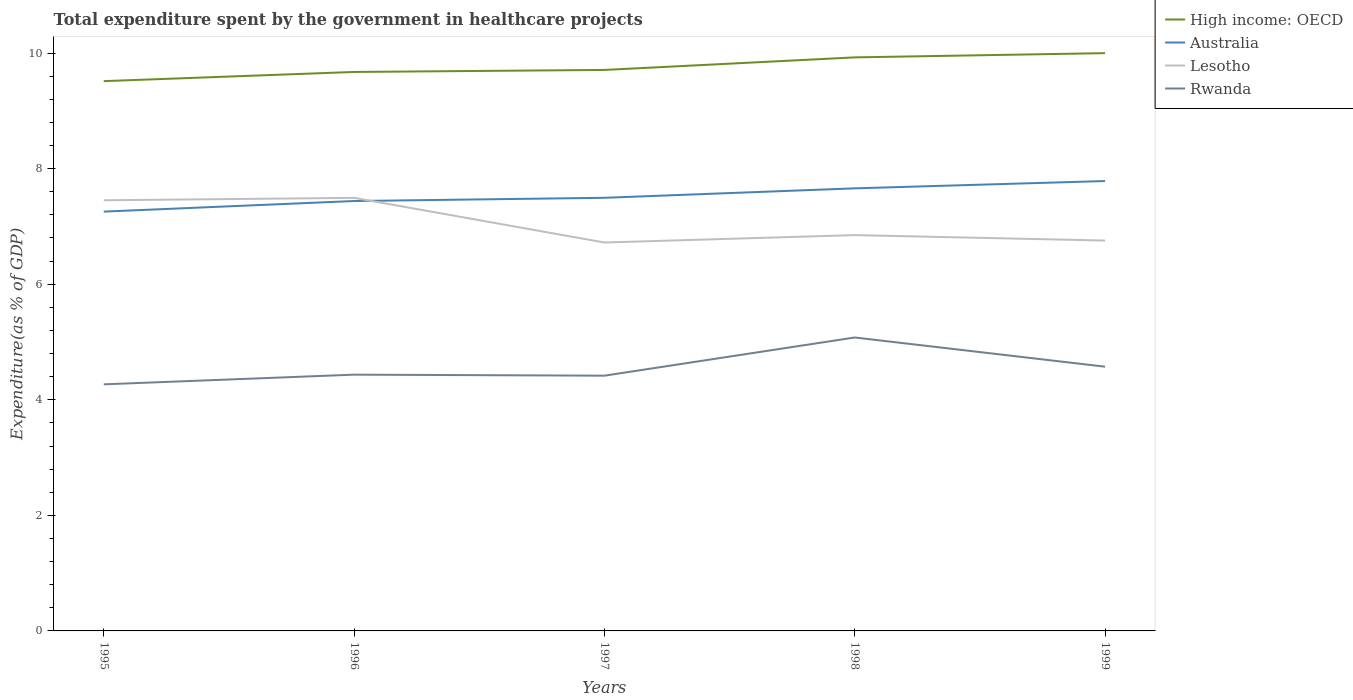How many different coloured lines are there?
Your answer should be compact. 4. Does the line corresponding to Lesotho intersect with the line corresponding to Rwanda?
Your answer should be very brief. No. Across all years, what is the maximum total expenditure spent by the government in healthcare projects in Australia?
Provide a succinct answer. 7.26. In which year was the total expenditure spent by the government in healthcare projects in Lesotho maximum?
Give a very brief answer. 1997. What is the total total expenditure spent by the government in healthcare projects in Australia in the graph?
Your answer should be compact. -0.24. What is the difference between the highest and the second highest total expenditure spent by the government in healthcare projects in Australia?
Your answer should be compact. 0.53. What is the difference between the highest and the lowest total expenditure spent by the government in healthcare projects in High income: OECD?
Give a very brief answer. 2. How many lines are there?
Make the answer very short. 4. How many years are there in the graph?
Your response must be concise. 5. What is the difference between two consecutive major ticks on the Y-axis?
Provide a succinct answer. 2. Does the graph contain any zero values?
Your answer should be compact. No. Does the graph contain grids?
Offer a very short reply. No. How many legend labels are there?
Keep it short and to the point. 4. How are the legend labels stacked?
Offer a terse response. Vertical. What is the title of the graph?
Offer a terse response. Total expenditure spent by the government in healthcare projects. Does "Kenya" appear as one of the legend labels in the graph?
Keep it short and to the point. No. What is the label or title of the X-axis?
Offer a very short reply. Years. What is the label or title of the Y-axis?
Provide a succinct answer. Expenditure(as % of GDP). What is the Expenditure(as % of GDP) of High income: OECD in 1995?
Your response must be concise. 9.51. What is the Expenditure(as % of GDP) in Australia in 1995?
Make the answer very short. 7.26. What is the Expenditure(as % of GDP) in Lesotho in 1995?
Your response must be concise. 7.45. What is the Expenditure(as % of GDP) in Rwanda in 1995?
Your answer should be compact. 4.27. What is the Expenditure(as % of GDP) of High income: OECD in 1996?
Your answer should be compact. 9.67. What is the Expenditure(as % of GDP) in Australia in 1996?
Offer a terse response. 7.44. What is the Expenditure(as % of GDP) of Lesotho in 1996?
Your response must be concise. 7.49. What is the Expenditure(as % of GDP) of Rwanda in 1996?
Provide a succinct answer. 4.44. What is the Expenditure(as % of GDP) of High income: OECD in 1997?
Provide a short and direct response. 9.71. What is the Expenditure(as % of GDP) of Australia in 1997?
Ensure brevity in your answer.  7.5. What is the Expenditure(as % of GDP) of Lesotho in 1997?
Make the answer very short. 6.72. What is the Expenditure(as % of GDP) in Rwanda in 1997?
Offer a very short reply. 4.42. What is the Expenditure(as % of GDP) of High income: OECD in 1998?
Your answer should be very brief. 9.93. What is the Expenditure(as % of GDP) of Australia in 1998?
Give a very brief answer. 7.66. What is the Expenditure(as % of GDP) of Lesotho in 1998?
Provide a succinct answer. 6.85. What is the Expenditure(as % of GDP) in Rwanda in 1998?
Offer a terse response. 5.08. What is the Expenditure(as % of GDP) in High income: OECD in 1999?
Your response must be concise. 10. What is the Expenditure(as % of GDP) of Australia in 1999?
Your response must be concise. 7.79. What is the Expenditure(as % of GDP) in Lesotho in 1999?
Offer a terse response. 6.76. What is the Expenditure(as % of GDP) of Rwanda in 1999?
Offer a terse response. 4.57. Across all years, what is the maximum Expenditure(as % of GDP) in High income: OECD?
Your response must be concise. 10. Across all years, what is the maximum Expenditure(as % of GDP) in Australia?
Keep it short and to the point. 7.79. Across all years, what is the maximum Expenditure(as % of GDP) of Lesotho?
Your answer should be compact. 7.49. Across all years, what is the maximum Expenditure(as % of GDP) of Rwanda?
Your response must be concise. 5.08. Across all years, what is the minimum Expenditure(as % of GDP) of High income: OECD?
Provide a short and direct response. 9.51. Across all years, what is the minimum Expenditure(as % of GDP) in Australia?
Provide a succinct answer. 7.26. Across all years, what is the minimum Expenditure(as % of GDP) of Lesotho?
Ensure brevity in your answer.  6.72. Across all years, what is the minimum Expenditure(as % of GDP) of Rwanda?
Offer a very short reply. 4.27. What is the total Expenditure(as % of GDP) in High income: OECD in the graph?
Provide a short and direct response. 48.82. What is the total Expenditure(as % of GDP) of Australia in the graph?
Your answer should be compact. 37.64. What is the total Expenditure(as % of GDP) in Lesotho in the graph?
Provide a short and direct response. 35.27. What is the total Expenditure(as % of GDP) of Rwanda in the graph?
Provide a succinct answer. 22.77. What is the difference between the Expenditure(as % of GDP) of High income: OECD in 1995 and that in 1996?
Your answer should be compact. -0.16. What is the difference between the Expenditure(as % of GDP) of Australia in 1995 and that in 1996?
Your answer should be very brief. -0.18. What is the difference between the Expenditure(as % of GDP) of Lesotho in 1995 and that in 1996?
Provide a succinct answer. -0.04. What is the difference between the Expenditure(as % of GDP) in Rwanda in 1995 and that in 1996?
Provide a succinct answer. -0.17. What is the difference between the Expenditure(as % of GDP) of High income: OECD in 1995 and that in 1997?
Give a very brief answer. -0.19. What is the difference between the Expenditure(as % of GDP) of Australia in 1995 and that in 1997?
Your answer should be very brief. -0.24. What is the difference between the Expenditure(as % of GDP) in Lesotho in 1995 and that in 1997?
Your answer should be compact. 0.73. What is the difference between the Expenditure(as % of GDP) of Rwanda in 1995 and that in 1997?
Make the answer very short. -0.15. What is the difference between the Expenditure(as % of GDP) in High income: OECD in 1995 and that in 1998?
Keep it short and to the point. -0.41. What is the difference between the Expenditure(as % of GDP) of Australia in 1995 and that in 1998?
Keep it short and to the point. -0.4. What is the difference between the Expenditure(as % of GDP) in Lesotho in 1995 and that in 1998?
Offer a very short reply. 0.6. What is the difference between the Expenditure(as % of GDP) in Rwanda in 1995 and that in 1998?
Provide a short and direct response. -0.81. What is the difference between the Expenditure(as % of GDP) of High income: OECD in 1995 and that in 1999?
Provide a succinct answer. -0.48. What is the difference between the Expenditure(as % of GDP) in Australia in 1995 and that in 1999?
Keep it short and to the point. -0.53. What is the difference between the Expenditure(as % of GDP) in Lesotho in 1995 and that in 1999?
Your answer should be compact. 0.7. What is the difference between the Expenditure(as % of GDP) of Rwanda in 1995 and that in 1999?
Your answer should be compact. -0.31. What is the difference between the Expenditure(as % of GDP) of High income: OECD in 1996 and that in 1997?
Make the answer very short. -0.03. What is the difference between the Expenditure(as % of GDP) of Australia in 1996 and that in 1997?
Give a very brief answer. -0.06. What is the difference between the Expenditure(as % of GDP) in Lesotho in 1996 and that in 1997?
Your response must be concise. 0.77. What is the difference between the Expenditure(as % of GDP) in Rwanda in 1996 and that in 1997?
Ensure brevity in your answer.  0.02. What is the difference between the Expenditure(as % of GDP) of High income: OECD in 1996 and that in 1998?
Keep it short and to the point. -0.25. What is the difference between the Expenditure(as % of GDP) of Australia in 1996 and that in 1998?
Offer a terse response. -0.22. What is the difference between the Expenditure(as % of GDP) in Lesotho in 1996 and that in 1998?
Give a very brief answer. 0.64. What is the difference between the Expenditure(as % of GDP) of Rwanda in 1996 and that in 1998?
Offer a terse response. -0.64. What is the difference between the Expenditure(as % of GDP) in High income: OECD in 1996 and that in 1999?
Ensure brevity in your answer.  -0.33. What is the difference between the Expenditure(as % of GDP) of Australia in 1996 and that in 1999?
Your answer should be compact. -0.35. What is the difference between the Expenditure(as % of GDP) in Lesotho in 1996 and that in 1999?
Give a very brief answer. 0.74. What is the difference between the Expenditure(as % of GDP) of Rwanda in 1996 and that in 1999?
Provide a succinct answer. -0.14. What is the difference between the Expenditure(as % of GDP) of High income: OECD in 1997 and that in 1998?
Offer a terse response. -0.22. What is the difference between the Expenditure(as % of GDP) of Australia in 1997 and that in 1998?
Your answer should be compact. -0.16. What is the difference between the Expenditure(as % of GDP) of Lesotho in 1997 and that in 1998?
Offer a terse response. -0.13. What is the difference between the Expenditure(as % of GDP) of Rwanda in 1997 and that in 1998?
Keep it short and to the point. -0.66. What is the difference between the Expenditure(as % of GDP) in High income: OECD in 1997 and that in 1999?
Offer a very short reply. -0.29. What is the difference between the Expenditure(as % of GDP) in Australia in 1997 and that in 1999?
Give a very brief answer. -0.29. What is the difference between the Expenditure(as % of GDP) in Lesotho in 1997 and that in 1999?
Offer a terse response. -0.03. What is the difference between the Expenditure(as % of GDP) of Rwanda in 1997 and that in 1999?
Offer a terse response. -0.16. What is the difference between the Expenditure(as % of GDP) in High income: OECD in 1998 and that in 1999?
Give a very brief answer. -0.07. What is the difference between the Expenditure(as % of GDP) of Australia in 1998 and that in 1999?
Give a very brief answer. -0.13. What is the difference between the Expenditure(as % of GDP) in Lesotho in 1998 and that in 1999?
Provide a succinct answer. 0.09. What is the difference between the Expenditure(as % of GDP) of Rwanda in 1998 and that in 1999?
Your answer should be compact. 0.51. What is the difference between the Expenditure(as % of GDP) in High income: OECD in 1995 and the Expenditure(as % of GDP) in Australia in 1996?
Make the answer very short. 2.07. What is the difference between the Expenditure(as % of GDP) in High income: OECD in 1995 and the Expenditure(as % of GDP) in Lesotho in 1996?
Keep it short and to the point. 2.02. What is the difference between the Expenditure(as % of GDP) in High income: OECD in 1995 and the Expenditure(as % of GDP) in Rwanda in 1996?
Your response must be concise. 5.08. What is the difference between the Expenditure(as % of GDP) of Australia in 1995 and the Expenditure(as % of GDP) of Lesotho in 1996?
Offer a very short reply. -0.24. What is the difference between the Expenditure(as % of GDP) in Australia in 1995 and the Expenditure(as % of GDP) in Rwanda in 1996?
Offer a very short reply. 2.82. What is the difference between the Expenditure(as % of GDP) of Lesotho in 1995 and the Expenditure(as % of GDP) of Rwanda in 1996?
Provide a succinct answer. 3.02. What is the difference between the Expenditure(as % of GDP) in High income: OECD in 1995 and the Expenditure(as % of GDP) in Australia in 1997?
Ensure brevity in your answer.  2.02. What is the difference between the Expenditure(as % of GDP) of High income: OECD in 1995 and the Expenditure(as % of GDP) of Lesotho in 1997?
Offer a very short reply. 2.79. What is the difference between the Expenditure(as % of GDP) in High income: OECD in 1995 and the Expenditure(as % of GDP) in Rwanda in 1997?
Your response must be concise. 5.1. What is the difference between the Expenditure(as % of GDP) of Australia in 1995 and the Expenditure(as % of GDP) of Lesotho in 1997?
Provide a short and direct response. 0.54. What is the difference between the Expenditure(as % of GDP) in Australia in 1995 and the Expenditure(as % of GDP) in Rwanda in 1997?
Your response must be concise. 2.84. What is the difference between the Expenditure(as % of GDP) in Lesotho in 1995 and the Expenditure(as % of GDP) in Rwanda in 1997?
Give a very brief answer. 3.04. What is the difference between the Expenditure(as % of GDP) in High income: OECD in 1995 and the Expenditure(as % of GDP) in Australia in 1998?
Provide a short and direct response. 1.86. What is the difference between the Expenditure(as % of GDP) of High income: OECD in 1995 and the Expenditure(as % of GDP) of Lesotho in 1998?
Give a very brief answer. 2.66. What is the difference between the Expenditure(as % of GDP) in High income: OECD in 1995 and the Expenditure(as % of GDP) in Rwanda in 1998?
Offer a terse response. 4.44. What is the difference between the Expenditure(as % of GDP) of Australia in 1995 and the Expenditure(as % of GDP) of Lesotho in 1998?
Provide a succinct answer. 0.41. What is the difference between the Expenditure(as % of GDP) of Australia in 1995 and the Expenditure(as % of GDP) of Rwanda in 1998?
Provide a short and direct response. 2.18. What is the difference between the Expenditure(as % of GDP) of Lesotho in 1995 and the Expenditure(as % of GDP) of Rwanda in 1998?
Offer a terse response. 2.37. What is the difference between the Expenditure(as % of GDP) in High income: OECD in 1995 and the Expenditure(as % of GDP) in Australia in 1999?
Make the answer very short. 1.73. What is the difference between the Expenditure(as % of GDP) in High income: OECD in 1995 and the Expenditure(as % of GDP) in Lesotho in 1999?
Your answer should be compact. 2.76. What is the difference between the Expenditure(as % of GDP) of High income: OECD in 1995 and the Expenditure(as % of GDP) of Rwanda in 1999?
Offer a terse response. 4.94. What is the difference between the Expenditure(as % of GDP) of Australia in 1995 and the Expenditure(as % of GDP) of Lesotho in 1999?
Keep it short and to the point. 0.5. What is the difference between the Expenditure(as % of GDP) in Australia in 1995 and the Expenditure(as % of GDP) in Rwanda in 1999?
Provide a short and direct response. 2.68. What is the difference between the Expenditure(as % of GDP) of Lesotho in 1995 and the Expenditure(as % of GDP) of Rwanda in 1999?
Keep it short and to the point. 2.88. What is the difference between the Expenditure(as % of GDP) of High income: OECD in 1996 and the Expenditure(as % of GDP) of Australia in 1997?
Offer a very short reply. 2.18. What is the difference between the Expenditure(as % of GDP) of High income: OECD in 1996 and the Expenditure(as % of GDP) of Lesotho in 1997?
Make the answer very short. 2.95. What is the difference between the Expenditure(as % of GDP) of High income: OECD in 1996 and the Expenditure(as % of GDP) of Rwanda in 1997?
Your answer should be compact. 5.26. What is the difference between the Expenditure(as % of GDP) in Australia in 1996 and the Expenditure(as % of GDP) in Lesotho in 1997?
Offer a terse response. 0.72. What is the difference between the Expenditure(as % of GDP) of Australia in 1996 and the Expenditure(as % of GDP) of Rwanda in 1997?
Provide a short and direct response. 3.02. What is the difference between the Expenditure(as % of GDP) in Lesotho in 1996 and the Expenditure(as % of GDP) in Rwanda in 1997?
Provide a short and direct response. 3.08. What is the difference between the Expenditure(as % of GDP) of High income: OECD in 1996 and the Expenditure(as % of GDP) of Australia in 1998?
Your answer should be very brief. 2.01. What is the difference between the Expenditure(as % of GDP) of High income: OECD in 1996 and the Expenditure(as % of GDP) of Lesotho in 1998?
Provide a succinct answer. 2.82. What is the difference between the Expenditure(as % of GDP) in High income: OECD in 1996 and the Expenditure(as % of GDP) in Rwanda in 1998?
Keep it short and to the point. 4.6. What is the difference between the Expenditure(as % of GDP) in Australia in 1996 and the Expenditure(as % of GDP) in Lesotho in 1998?
Offer a terse response. 0.59. What is the difference between the Expenditure(as % of GDP) in Australia in 1996 and the Expenditure(as % of GDP) in Rwanda in 1998?
Offer a very short reply. 2.36. What is the difference between the Expenditure(as % of GDP) in Lesotho in 1996 and the Expenditure(as % of GDP) in Rwanda in 1998?
Your answer should be compact. 2.42. What is the difference between the Expenditure(as % of GDP) in High income: OECD in 1996 and the Expenditure(as % of GDP) in Australia in 1999?
Make the answer very short. 1.89. What is the difference between the Expenditure(as % of GDP) of High income: OECD in 1996 and the Expenditure(as % of GDP) of Lesotho in 1999?
Make the answer very short. 2.92. What is the difference between the Expenditure(as % of GDP) in High income: OECD in 1996 and the Expenditure(as % of GDP) in Rwanda in 1999?
Ensure brevity in your answer.  5.1. What is the difference between the Expenditure(as % of GDP) of Australia in 1996 and the Expenditure(as % of GDP) of Lesotho in 1999?
Your response must be concise. 0.68. What is the difference between the Expenditure(as % of GDP) in Australia in 1996 and the Expenditure(as % of GDP) in Rwanda in 1999?
Offer a very short reply. 2.87. What is the difference between the Expenditure(as % of GDP) in Lesotho in 1996 and the Expenditure(as % of GDP) in Rwanda in 1999?
Ensure brevity in your answer.  2.92. What is the difference between the Expenditure(as % of GDP) of High income: OECD in 1997 and the Expenditure(as % of GDP) of Australia in 1998?
Your answer should be very brief. 2.05. What is the difference between the Expenditure(as % of GDP) in High income: OECD in 1997 and the Expenditure(as % of GDP) in Lesotho in 1998?
Make the answer very short. 2.86. What is the difference between the Expenditure(as % of GDP) in High income: OECD in 1997 and the Expenditure(as % of GDP) in Rwanda in 1998?
Make the answer very short. 4.63. What is the difference between the Expenditure(as % of GDP) of Australia in 1997 and the Expenditure(as % of GDP) of Lesotho in 1998?
Your answer should be compact. 0.65. What is the difference between the Expenditure(as % of GDP) in Australia in 1997 and the Expenditure(as % of GDP) in Rwanda in 1998?
Your response must be concise. 2.42. What is the difference between the Expenditure(as % of GDP) of Lesotho in 1997 and the Expenditure(as % of GDP) of Rwanda in 1998?
Give a very brief answer. 1.64. What is the difference between the Expenditure(as % of GDP) of High income: OECD in 1997 and the Expenditure(as % of GDP) of Australia in 1999?
Give a very brief answer. 1.92. What is the difference between the Expenditure(as % of GDP) of High income: OECD in 1997 and the Expenditure(as % of GDP) of Lesotho in 1999?
Provide a short and direct response. 2.95. What is the difference between the Expenditure(as % of GDP) in High income: OECD in 1997 and the Expenditure(as % of GDP) in Rwanda in 1999?
Your response must be concise. 5.14. What is the difference between the Expenditure(as % of GDP) of Australia in 1997 and the Expenditure(as % of GDP) of Lesotho in 1999?
Provide a short and direct response. 0.74. What is the difference between the Expenditure(as % of GDP) of Australia in 1997 and the Expenditure(as % of GDP) of Rwanda in 1999?
Your response must be concise. 2.92. What is the difference between the Expenditure(as % of GDP) of Lesotho in 1997 and the Expenditure(as % of GDP) of Rwanda in 1999?
Ensure brevity in your answer.  2.15. What is the difference between the Expenditure(as % of GDP) of High income: OECD in 1998 and the Expenditure(as % of GDP) of Australia in 1999?
Provide a succinct answer. 2.14. What is the difference between the Expenditure(as % of GDP) of High income: OECD in 1998 and the Expenditure(as % of GDP) of Lesotho in 1999?
Offer a very short reply. 3.17. What is the difference between the Expenditure(as % of GDP) in High income: OECD in 1998 and the Expenditure(as % of GDP) in Rwanda in 1999?
Keep it short and to the point. 5.35. What is the difference between the Expenditure(as % of GDP) of Australia in 1998 and the Expenditure(as % of GDP) of Lesotho in 1999?
Your answer should be compact. 0.9. What is the difference between the Expenditure(as % of GDP) in Australia in 1998 and the Expenditure(as % of GDP) in Rwanda in 1999?
Provide a succinct answer. 3.09. What is the difference between the Expenditure(as % of GDP) of Lesotho in 1998 and the Expenditure(as % of GDP) of Rwanda in 1999?
Provide a short and direct response. 2.28. What is the average Expenditure(as % of GDP) of High income: OECD per year?
Your answer should be compact. 9.76. What is the average Expenditure(as % of GDP) in Australia per year?
Your response must be concise. 7.53. What is the average Expenditure(as % of GDP) in Lesotho per year?
Ensure brevity in your answer.  7.05. What is the average Expenditure(as % of GDP) of Rwanda per year?
Make the answer very short. 4.55. In the year 1995, what is the difference between the Expenditure(as % of GDP) of High income: OECD and Expenditure(as % of GDP) of Australia?
Offer a terse response. 2.26. In the year 1995, what is the difference between the Expenditure(as % of GDP) of High income: OECD and Expenditure(as % of GDP) of Lesotho?
Your response must be concise. 2.06. In the year 1995, what is the difference between the Expenditure(as % of GDP) in High income: OECD and Expenditure(as % of GDP) in Rwanda?
Keep it short and to the point. 5.25. In the year 1995, what is the difference between the Expenditure(as % of GDP) in Australia and Expenditure(as % of GDP) in Lesotho?
Give a very brief answer. -0.2. In the year 1995, what is the difference between the Expenditure(as % of GDP) in Australia and Expenditure(as % of GDP) in Rwanda?
Ensure brevity in your answer.  2.99. In the year 1995, what is the difference between the Expenditure(as % of GDP) in Lesotho and Expenditure(as % of GDP) in Rwanda?
Your answer should be very brief. 3.19. In the year 1996, what is the difference between the Expenditure(as % of GDP) of High income: OECD and Expenditure(as % of GDP) of Australia?
Keep it short and to the point. 2.23. In the year 1996, what is the difference between the Expenditure(as % of GDP) of High income: OECD and Expenditure(as % of GDP) of Lesotho?
Your answer should be very brief. 2.18. In the year 1996, what is the difference between the Expenditure(as % of GDP) in High income: OECD and Expenditure(as % of GDP) in Rwanda?
Make the answer very short. 5.24. In the year 1996, what is the difference between the Expenditure(as % of GDP) in Australia and Expenditure(as % of GDP) in Lesotho?
Offer a very short reply. -0.05. In the year 1996, what is the difference between the Expenditure(as % of GDP) in Australia and Expenditure(as % of GDP) in Rwanda?
Keep it short and to the point. 3. In the year 1996, what is the difference between the Expenditure(as % of GDP) in Lesotho and Expenditure(as % of GDP) in Rwanda?
Give a very brief answer. 3.06. In the year 1997, what is the difference between the Expenditure(as % of GDP) of High income: OECD and Expenditure(as % of GDP) of Australia?
Make the answer very short. 2.21. In the year 1997, what is the difference between the Expenditure(as % of GDP) in High income: OECD and Expenditure(as % of GDP) in Lesotho?
Keep it short and to the point. 2.99. In the year 1997, what is the difference between the Expenditure(as % of GDP) of High income: OECD and Expenditure(as % of GDP) of Rwanda?
Keep it short and to the point. 5.29. In the year 1997, what is the difference between the Expenditure(as % of GDP) in Australia and Expenditure(as % of GDP) in Lesotho?
Keep it short and to the point. 0.77. In the year 1997, what is the difference between the Expenditure(as % of GDP) of Australia and Expenditure(as % of GDP) of Rwanda?
Your answer should be compact. 3.08. In the year 1997, what is the difference between the Expenditure(as % of GDP) of Lesotho and Expenditure(as % of GDP) of Rwanda?
Ensure brevity in your answer.  2.3. In the year 1998, what is the difference between the Expenditure(as % of GDP) of High income: OECD and Expenditure(as % of GDP) of Australia?
Offer a terse response. 2.27. In the year 1998, what is the difference between the Expenditure(as % of GDP) in High income: OECD and Expenditure(as % of GDP) in Lesotho?
Ensure brevity in your answer.  3.08. In the year 1998, what is the difference between the Expenditure(as % of GDP) of High income: OECD and Expenditure(as % of GDP) of Rwanda?
Offer a terse response. 4.85. In the year 1998, what is the difference between the Expenditure(as % of GDP) in Australia and Expenditure(as % of GDP) in Lesotho?
Make the answer very short. 0.81. In the year 1998, what is the difference between the Expenditure(as % of GDP) in Australia and Expenditure(as % of GDP) in Rwanda?
Your response must be concise. 2.58. In the year 1998, what is the difference between the Expenditure(as % of GDP) in Lesotho and Expenditure(as % of GDP) in Rwanda?
Ensure brevity in your answer.  1.77. In the year 1999, what is the difference between the Expenditure(as % of GDP) of High income: OECD and Expenditure(as % of GDP) of Australia?
Provide a succinct answer. 2.21. In the year 1999, what is the difference between the Expenditure(as % of GDP) of High income: OECD and Expenditure(as % of GDP) of Lesotho?
Your response must be concise. 3.24. In the year 1999, what is the difference between the Expenditure(as % of GDP) of High income: OECD and Expenditure(as % of GDP) of Rwanda?
Keep it short and to the point. 5.43. In the year 1999, what is the difference between the Expenditure(as % of GDP) of Australia and Expenditure(as % of GDP) of Lesotho?
Give a very brief answer. 1.03. In the year 1999, what is the difference between the Expenditure(as % of GDP) of Australia and Expenditure(as % of GDP) of Rwanda?
Offer a very short reply. 3.21. In the year 1999, what is the difference between the Expenditure(as % of GDP) of Lesotho and Expenditure(as % of GDP) of Rwanda?
Provide a short and direct response. 2.18. What is the ratio of the Expenditure(as % of GDP) of High income: OECD in 1995 to that in 1996?
Offer a terse response. 0.98. What is the ratio of the Expenditure(as % of GDP) in Australia in 1995 to that in 1996?
Your answer should be very brief. 0.98. What is the ratio of the Expenditure(as % of GDP) of Lesotho in 1995 to that in 1996?
Your answer should be very brief. 0.99. What is the ratio of the Expenditure(as % of GDP) in Rwanda in 1995 to that in 1996?
Offer a very short reply. 0.96. What is the ratio of the Expenditure(as % of GDP) in High income: OECD in 1995 to that in 1997?
Your response must be concise. 0.98. What is the ratio of the Expenditure(as % of GDP) of Australia in 1995 to that in 1997?
Provide a short and direct response. 0.97. What is the ratio of the Expenditure(as % of GDP) of Lesotho in 1995 to that in 1997?
Offer a terse response. 1.11. What is the ratio of the Expenditure(as % of GDP) in Rwanda in 1995 to that in 1997?
Make the answer very short. 0.97. What is the ratio of the Expenditure(as % of GDP) in High income: OECD in 1995 to that in 1998?
Your answer should be very brief. 0.96. What is the ratio of the Expenditure(as % of GDP) of Lesotho in 1995 to that in 1998?
Provide a succinct answer. 1.09. What is the ratio of the Expenditure(as % of GDP) in Rwanda in 1995 to that in 1998?
Keep it short and to the point. 0.84. What is the ratio of the Expenditure(as % of GDP) of High income: OECD in 1995 to that in 1999?
Offer a terse response. 0.95. What is the ratio of the Expenditure(as % of GDP) in Australia in 1995 to that in 1999?
Keep it short and to the point. 0.93. What is the ratio of the Expenditure(as % of GDP) in Lesotho in 1995 to that in 1999?
Keep it short and to the point. 1.1. What is the ratio of the Expenditure(as % of GDP) in Rwanda in 1995 to that in 1999?
Your response must be concise. 0.93. What is the ratio of the Expenditure(as % of GDP) of High income: OECD in 1996 to that in 1997?
Offer a very short reply. 1. What is the ratio of the Expenditure(as % of GDP) in Lesotho in 1996 to that in 1997?
Your answer should be compact. 1.11. What is the ratio of the Expenditure(as % of GDP) in Rwanda in 1996 to that in 1997?
Offer a terse response. 1. What is the ratio of the Expenditure(as % of GDP) in High income: OECD in 1996 to that in 1998?
Keep it short and to the point. 0.97. What is the ratio of the Expenditure(as % of GDP) of Australia in 1996 to that in 1998?
Provide a short and direct response. 0.97. What is the ratio of the Expenditure(as % of GDP) in Lesotho in 1996 to that in 1998?
Your answer should be compact. 1.09. What is the ratio of the Expenditure(as % of GDP) of Rwanda in 1996 to that in 1998?
Provide a short and direct response. 0.87. What is the ratio of the Expenditure(as % of GDP) in High income: OECD in 1996 to that in 1999?
Provide a short and direct response. 0.97. What is the ratio of the Expenditure(as % of GDP) in Australia in 1996 to that in 1999?
Make the answer very short. 0.96. What is the ratio of the Expenditure(as % of GDP) of Lesotho in 1996 to that in 1999?
Your answer should be compact. 1.11. What is the ratio of the Expenditure(as % of GDP) of Rwanda in 1996 to that in 1999?
Your answer should be compact. 0.97. What is the ratio of the Expenditure(as % of GDP) in High income: OECD in 1997 to that in 1998?
Your answer should be compact. 0.98. What is the ratio of the Expenditure(as % of GDP) in Australia in 1997 to that in 1998?
Your response must be concise. 0.98. What is the ratio of the Expenditure(as % of GDP) of Lesotho in 1997 to that in 1998?
Provide a succinct answer. 0.98. What is the ratio of the Expenditure(as % of GDP) in Rwanda in 1997 to that in 1998?
Your answer should be very brief. 0.87. What is the ratio of the Expenditure(as % of GDP) in High income: OECD in 1997 to that in 1999?
Offer a terse response. 0.97. What is the ratio of the Expenditure(as % of GDP) of Australia in 1997 to that in 1999?
Make the answer very short. 0.96. What is the ratio of the Expenditure(as % of GDP) of Lesotho in 1997 to that in 1999?
Provide a short and direct response. 0.99. What is the ratio of the Expenditure(as % of GDP) of Rwanda in 1997 to that in 1999?
Offer a very short reply. 0.97. What is the ratio of the Expenditure(as % of GDP) of Australia in 1998 to that in 1999?
Make the answer very short. 0.98. What is the ratio of the Expenditure(as % of GDP) of Rwanda in 1998 to that in 1999?
Offer a terse response. 1.11. What is the difference between the highest and the second highest Expenditure(as % of GDP) of High income: OECD?
Your answer should be very brief. 0.07. What is the difference between the highest and the second highest Expenditure(as % of GDP) in Australia?
Give a very brief answer. 0.13. What is the difference between the highest and the second highest Expenditure(as % of GDP) of Lesotho?
Provide a short and direct response. 0.04. What is the difference between the highest and the second highest Expenditure(as % of GDP) in Rwanda?
Give a very brief answer. 0.51. What is the difference between the highest and the lowest Expenditure(as % of GDP) of High income: OECD?
Your answer should be compact. 0.48. What is the difference between the highest and the lowest Expenditure(as % of GDP) in Australia?
Give a very brief answer. 0.53. What is the difference between the highest and the lowest Expenditure(as % of GDP) of Lesotho?
Ensure brevity in your answer.  0.77. What is the difference between the highest and the lowest Expenditure(as % of GDP) of Rwanda?
Provide a succinct answer. 0.81. 